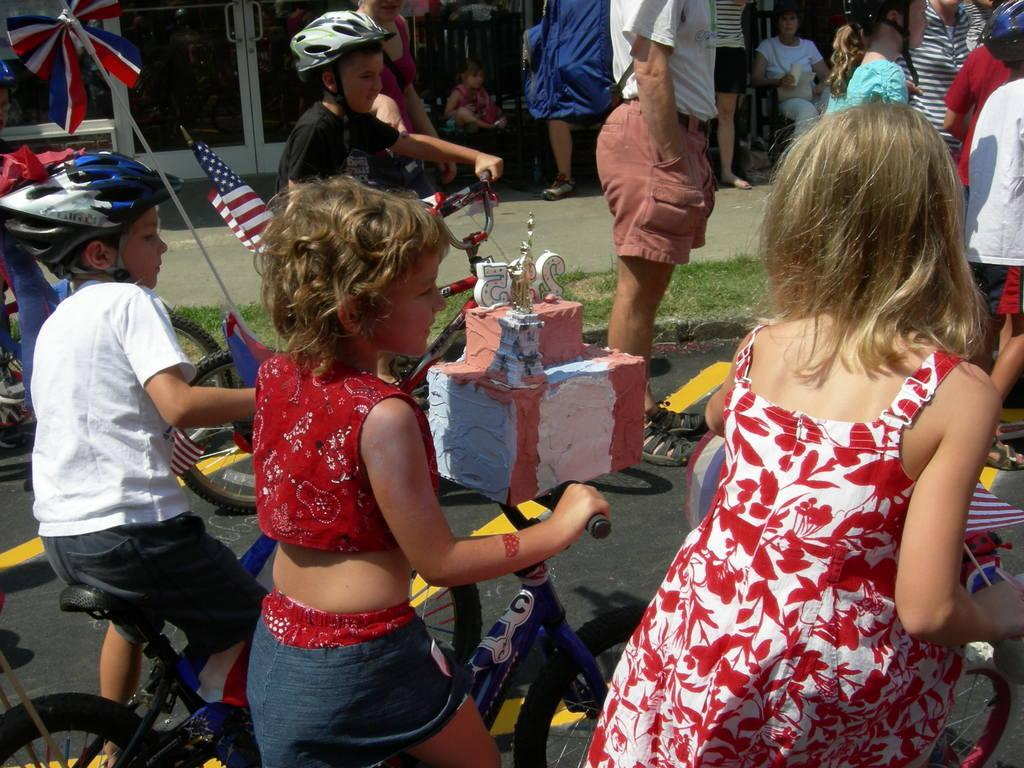How many people are in the image? There are four people in the image. What are the people doing in the image? The four people are sitting on bicycles. What type of silk fabric is draped over the point in the image? There is no silk fabric or point present in the image; it features four people sitting on bicycles. 